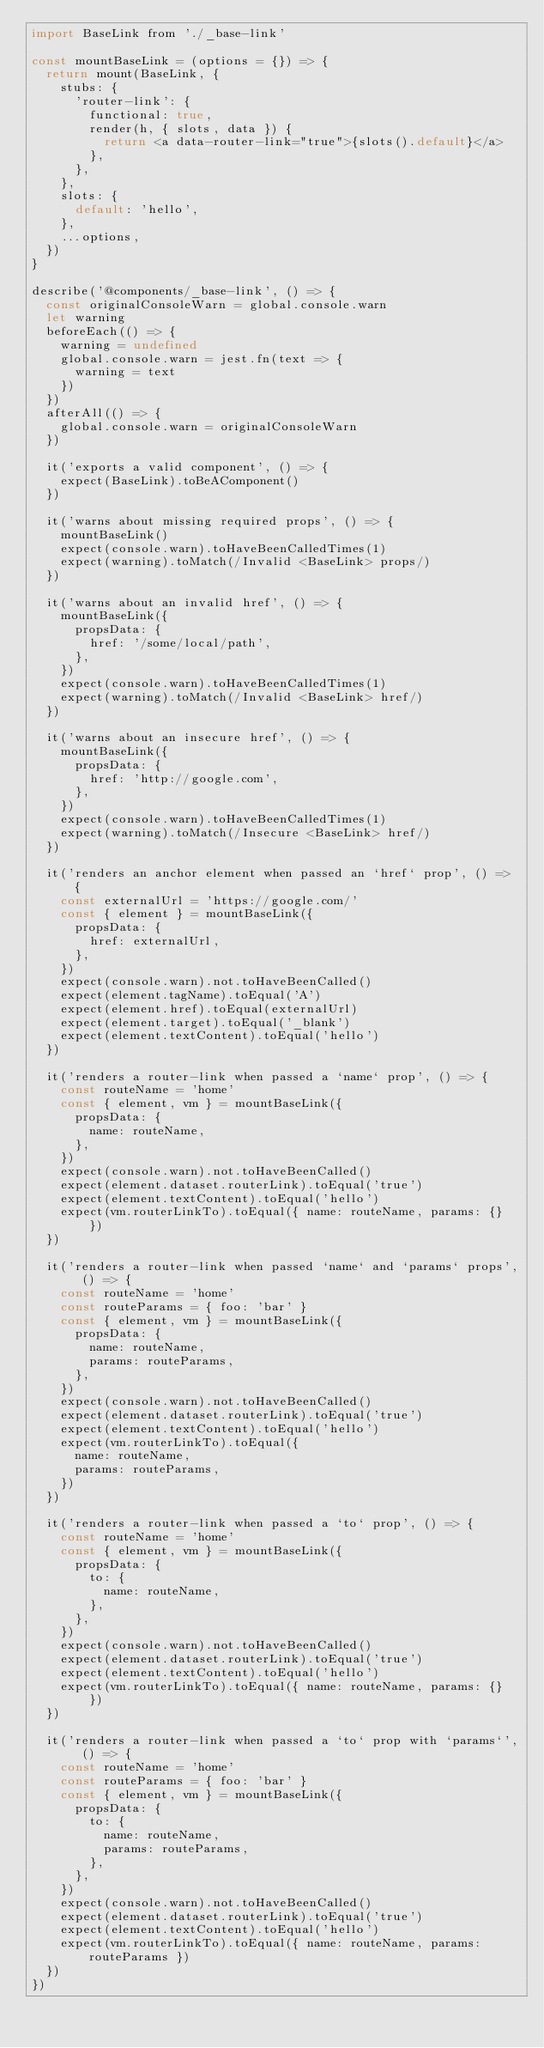<code> <loc_0><loc_0><loc_500><loc_500><_JavaScript_>import BaseLink from './_base-link'

const mountBaseLink = (options = {}) => {
  return mount(BaseLink, {
    stubs: {
      'router-link': {
        functional: true,
        render(h, { slots, data }) {
          return <a data-router-link="true">{slots().default}</a>
        },
      },
    },
    slots: {
      default: 'hello',
    },
    ...options,
  })
}

describe('@components/_base-link', () => {
  const originalConsoleWarn = global.console.warn
  let warning
  beforeEach(() => {
    warning = undefined
    global.console.warn = jest.fn(text => {
      warning = text
    })
  })
  afterAll(() => {
    global.console.warn = originalConsoleWarn
  })

  it('exports a valid component', () => {
    expect(BaseLink).toBeAComponent()
  })

  it('warns about missing required props', () => {
    mountBaseLink()
    expect(console.warn).toHaveBeenCalledTimes(1)
    expect(warning).toMatch(/Invalid <BaseLink> props/)
  })

  it('warns about an invalid href', () => {
    mountBaseLink({
      propsData: {
        href: '/some/local/path',
      },
    })
    expect(console.warn).toHaveBeenCalledTimes(1)
    expect(warning).toMatch(/Invalid <BaseLink> href/)
  })

  it('warns about an insecure href', () => {
    mountBaseLink({
      propsData: {
        href: 'http://google.com',
      },
    })
    expect(console.warn).toHaveBeenCalledTimes(1)
    expect(warning).toMatch(/Insecure <BaseLink> href/)
  })

  it('renders an anchor element when passed an `href` prop', () => {
    const externalUrl = 'https://google.com/'
    const { element } = mountBaseLink({
      propsData: {
        href: externalUrl,
      },
    })
    expect(console.warn).not.toHaveBeenCalled()
    expect(element.tagName).toEqual('A')
    expect(element.href).toEqual(externalUrl)
    expect(element.target).toEqual('_blank')
    expect(element.textContent).toEqual('hello')
  })

  it('renders a router-link when passed a `name` prop', () => {
    const routeName = 'home'
    const { element, vm } = mountBaseLink({
      propsData: {
        name: routeName,
      },
    })
    expect(console.warn).not.toHaveBeenCalled()
    expect(element.dataset.routerLink).toEqual('true')
    expect(element.textContent).toEqual('hello')
    expect(vm.routerLinkTo).toEqual({ name: routeName, params: {} })
  })

  it('renders a router-link when passed `name` and `params` props', () => {
    const routeName = 'home'
    const routeParams = { foo: 'bar' }
    const { element, vm } = mountBaseLink({
      propsData: {
        name: routeName,
        params: routeParams,
      },
    })
    expect(console.warn).not.toHaveBeenCalled()
    expect(element.dataset.routerLink).toEqual('true')
    expect(element.textContent).toEqual('hello')
    expect(vm.routerLinkTo).toEqual({
      name: routeName,
      params: routeParams,
    })
  })

  it('renders a router-link when passed a `to` prop', () => {
    const routeName = 'home'
    const { element, vm } = mountBaseLink({
      propsData: {
        to: {
          name: routeName,
        },
      },
    })
    expect(console.warn).not.toHaveBeenCalled()
    expect(element.dataset.routerLink).toEqual('true')
    expect(element.textContent).toEqual('hello')
    expect(vm.routerLinkTo).toEqual({ name: routeName, params: {} })
  })

  it('renders a router-link when passed a `to` prop with `params`', () => {
    const routeName = 'home'
    const routeParams = { foo: 'bar' }
    const { element, vm } = mountBaseLink({
      propsData: {
        to: {
          name: routeName,
          params: routeParams,
        },
      },
    })
    expect(console.warn).not.toHaveBeenCalled()
    expect(element.dataset.routerLink).toEqual('true')
    expect(element.textContent).toEqual('hello')
    expect(vm.routerLinkTo).toEqual({ name: routeName, params: routeParams })
  })
})
</code> 